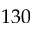Convert formula to latex. <formula><loc_0><loc_0><loc_500><loc_500>1 3 0</formula> 